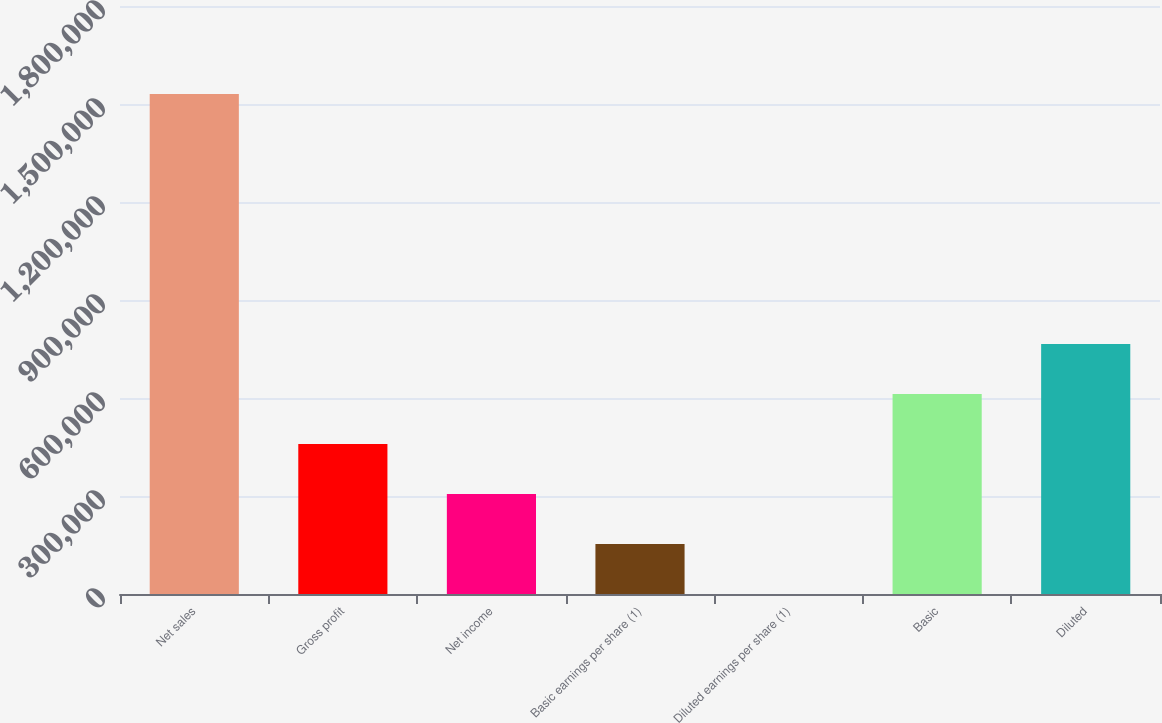<chart> <loc_0><loc_0><loc_500><loc_500><bar_chart><fcel>Net sales<fcel>Gross profit<fcel>Net income<fcel>Basic earnings per share (1)<fcel>Diluted earnings per share (1)<fcel>Basic<fcel>Diluted<nl><fcel>1.53035e+06<fcel>459105<fcel>306070<fcel>153035<fcel>0.26<fcel>612140<fcel>765175<nl></chart> 